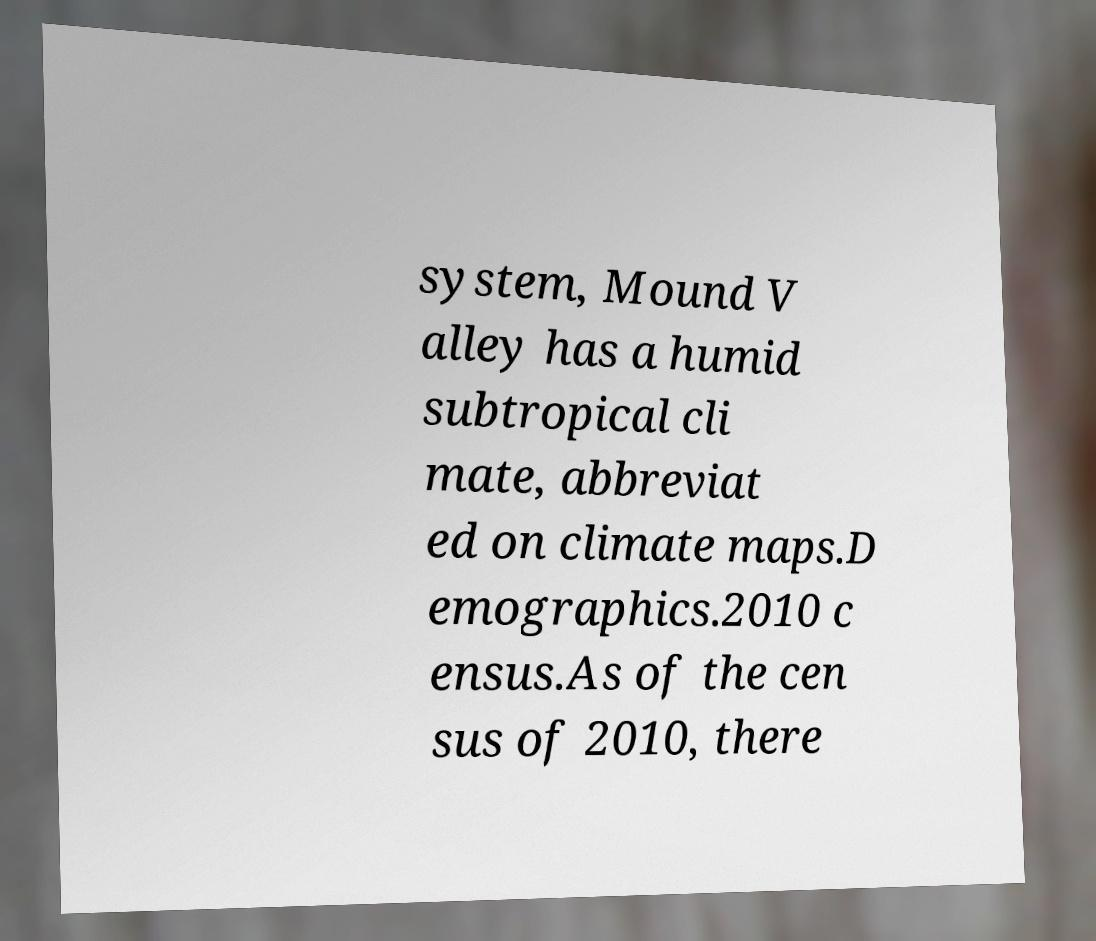Could you assist in decoding the text presented in this image and type it out clearly? system, Mound V alley has a humid subtropical cli mate, abbreviat ed on climate maps.D emographics.2010 c ensus.As of the cen sus of 2010, there 